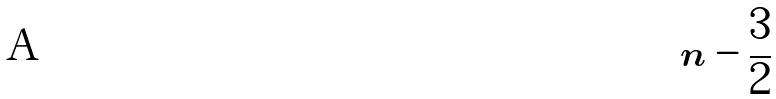Convert formula to latex. <formula><loc_0><loc_0><loc_500><loc_500>n - \frac { 3 } { 2 }</formula> 